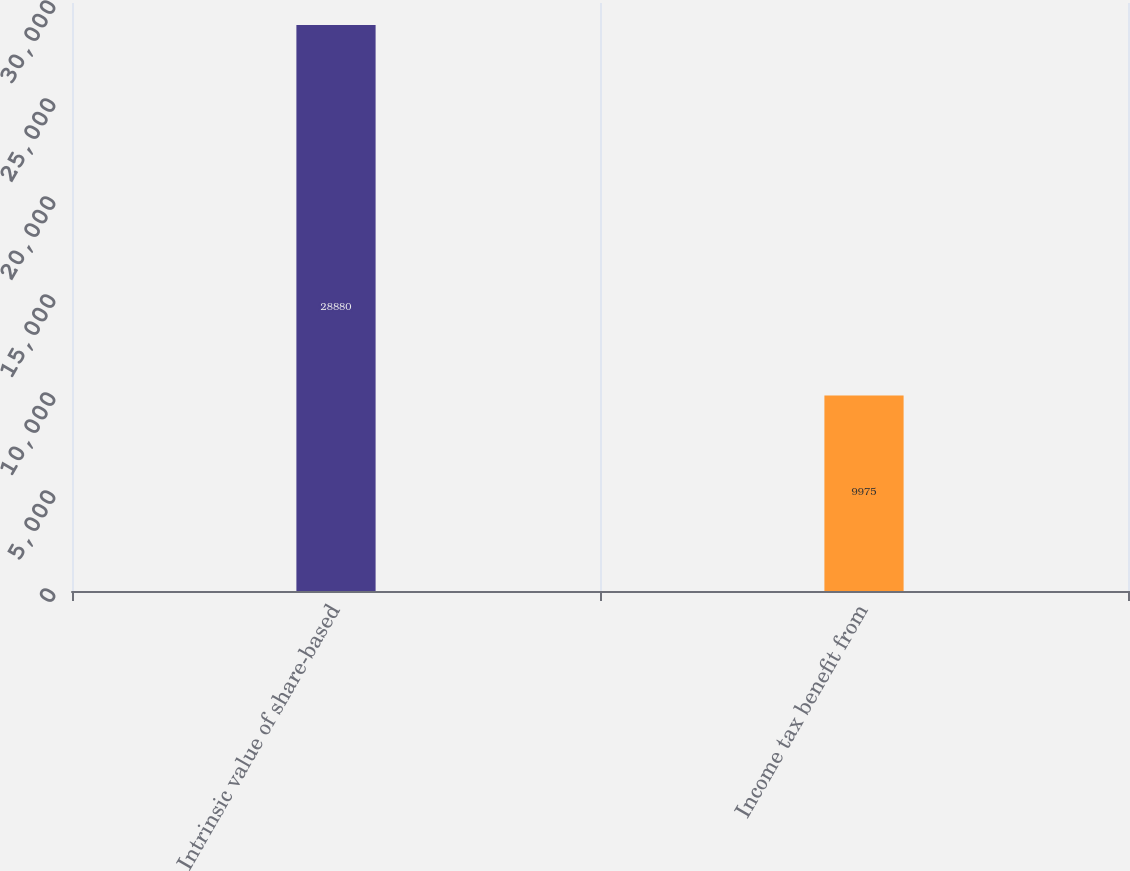Convert chart to OTSL. <chart><loc_0><loc_0><loc_500><loc_500><bar_chart><fcel>Intrinsic value of share-based<fcel>Income tax benefit from<nl><fcel>28880<fcel>9975<nl></chart> 